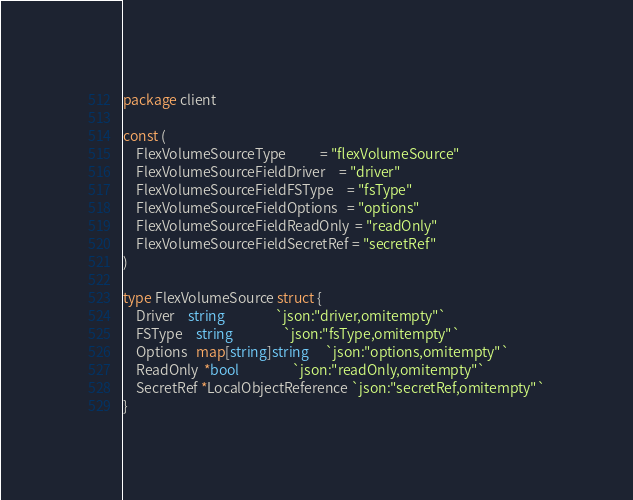<code> <loc_0><loc_0><loc_500><loc_500><_Go_>package client

const (
	FlexVolumeSourceType           = "flexVolumeSource"
	FlexVolumeSourceFieldDriver    = "driver"
	FlexVolumeSourceFieldFSType    = "fsType"
	FlexVolumeSourceFieldOptions   = "options"
	FlexVolumeSourceFieldReadOnly  = "readOnly"
	FlexVolumeSourceFieldSecretRef = "secretRef"
)

type FlexVolumeSource struct {
	Driver    string                `json:"driver,omitempty"`
	FSType    string                `json:"fsType,omitempty"`
	Options   map[string]string     `json:"options,omitempty"`
	ReadOnly  *bool                 `json:"readOnly,omitempty"`
	SecretRef *LocalObjectReference `json:"secretRef,omitempty"`
}
</code> 